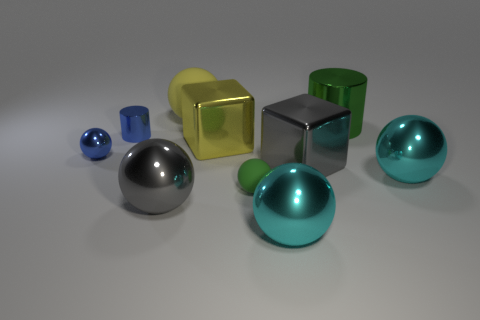Do the gray shiny cube and the yellow rubber thing have the same size?
Provide a short and direct response. Yes. What is the shape of the small metallic object on the right side of the blue sphere?
Your response must be concise. Cylinder. Are there any purple things of the same size as the yellow metal object?
Ensure brevity in your answer.  No. There is a cylinder that is the same size as the green rubber thing; what is it made of?
Your answer should be very brief. Metal. There is a gray thing that is right of the large rubber sphere; what is its size?
Keep it short and to the point. Large. The green cylinder has what size?
Keep it short and to the point. Large. There is a yellow matte ball; is its size the same as the rubber ball that is in front of the small metal sphere?
Your response must be concise. No. What color is the big metal cube that is on the right side of the green rubber thing that is on the left side of the big metal cylinder?
Ensure brevity in your answer.  Gray. Are there the same number of blue spheres that are right of the tiny blue ball and large gray metal blocks behind the green metallic cylinder?
Your answer should be very brief. Yes. Are the gray thing that is to the left of the small matte object and the small green sphere made of the same material?
Offer a terse response. No. 